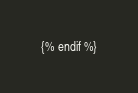Convert code to text. <code><loc_0><loc_0><loc_500><loc_500><_XML_>{% endif %}</code> 